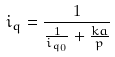Convert formula to latex. <formula><loc_0><loc_0><loc_500><loc_500>i _ { q } = \frac { 1 } { \frac { 1 } { i _ { q _ { 0 } } } + \frac { k a } { p } }</formula> 